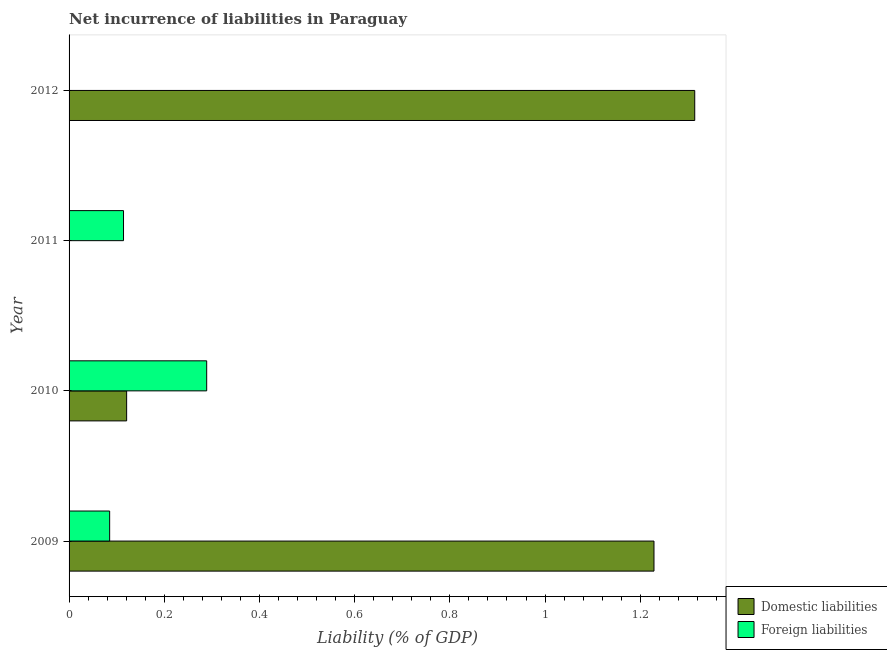How many different coloured bars are there?
Give a very brief answer. 2. Are the number of bars on each tick of the Y-axis equal?
Make the answer very short. No. What is the incurrence of foreign liabilities in 2011?
Keep it short and to the point. 0.11. Across all years, what is the maximum incurrence of foreign liabilities?
Give a very brief answer. 0.29. Across all years, what is the minimum incurrence of foreign liabilities?
Provide a short and direct response. 0. In which year was the incurrence of domestic liabilities maximum?
Ensure brevity in your answer.  2012. What is the total incurrence of foreign liabilities in the graph?
Offer a terse response. 0.49. What is the difference between the incurrence of foreign liabilities in 2009 and that in 2010?
Your response must be concise. -0.2. What is the difference between the incurrence of foreign liabilities in 2011 and the incurrence of domestic liabilities in 2012?
Keep it short and to the point. -1.2. What is the average incurrence of domestic liabilities per year?
Your answer should be very brief. 0.67. In the year 2010, what is the difference between the incurrence of domestic liabilities and incurrence of foreign liabilities?
Your response must be concise. -0.17. In how many years, is the incurrence of foreign liabilities greater than 0.2 %?
Provide a short and direct response. 1. What is the ratio of the incurrence of foreign liabilities in 2009 to that in 2011?
Keep it short and to the point. 0.74. Is the incurrence of domestic liabilities in 2010 less than that in 2012?
Provide a succinct answer. Yes. What is the difference between the highest and the second highest incurrence of domestic liabilities?
Make the answer very short. 0.09. What is the difference between the highest and the lowest incurrence of foreign liabilities?
Offer a very short reply. 0.29. In how many years, is the incurrence of domestic liabilities greater than the average incurrence of domestic liabilities taken over all years?
Provide a short and direct response. 2. What is the difference between two consecutive major ticks on the X-axis?
Your answer should be compact. 0.2. Does the graph contain grids?
Offer a very short reply. No. How many legend labels are there?
Ensure brevity in your answer.  2. How are the legend labels stacked?
Keep it short and to the point. Vertical. What is the title of the graph?
Offer a terse response. Net incurrence of liabilities in Paraguay. What is the label or title of the X-axis?
Ensure brevity in your answer.  Liability (% of GDP). What is the Liability (% of GDP) in Domestic liabilities in 2009?
Offer a very short reply. 1.23. What is the Liability (% of GDP) of Foreign liabilities in 2009?
Provide a short and direct response. 0.09. What is the Liability (% of GDP) of Domestic liabilities in 2010?
Keep it short and to the point. 0.12. What is the Liability (% of GDP) in Foreign liabilities in 2010?
Your response must be concise. 0.29. What is the Liability (% of GDP) of Foreign liabilities in 2011?
Keep it short and to the point. 0.11. What is the Liability (% of GDP) of Domestic liabilities in 2012?
Keep it short and to the point. 1.31. What is the Liability (% of GDP) in Foreign liabilities in 2012?
Offer a very short reply. 0. Across all years, what is the maximum Liability (% of GDP) in Domestic liabilities?
Keep it short and to the point. 1.31. Across all years, what is the maximum Liability (% of GDP) of Foreign liabilities?
Make the answer very short. 0.29. Across all years, what is the minimum Liability (% of GDP) in Domestic liabilities?
Your response must be concise. 0. What is the total Liability (% of GDP) of Domestic liabilities in the graph?
Keep it short and to the point. 2.66. What is the total Liability (% of GDP) of Foreign liabilities in the graph?
Provide a succinct answer. 0.49. What is the difference between the Liability (% of GDP) in Domestic liabilities in 2009 and that in 2010?
Make the answer very short. 1.11. What is the difference between the Liability (% of GDP) in Foreign liabilities in 2009 and that in 2010?
Offer a terse response. -0.2. What is the difference between the Liability (% of GDP) in Foreign liabilities in 2009 and that in 2011?
Provide a short and direct response. -0.03. What is the difference between the Liability (% of GDP) of Domestic liabilities in 2009 and that in 2012?
Give a very brief answer. -0.09. What is the difference between the Liability (% of GDP) in Foreign liabilities in 2010 and that in 2011?
Ensure brevity in your answer.  0.17. What is the difference between the Liability (% of GDP) of Domestic liabilities in 2010 and that in 2012?
Give a very brief answer. -1.19. What is the difference between the Liability (% of GDP) of Domestic liabilities in 2009 and the Liability (% of GDP) of Foreign liabilities in 2010?
Offer a very short reply. 0.94. What is the difference between the Liability (% of GDP) of Domestic liabilities in 2009 and the Liability (% of GDP) of Foreign liabilities in 2011?
Ensure brevity in your answer.  1.11. What is the difference between the Liability (% of GDP) of Domestic liabilities in 2010 and the Liability (% of GDP) of Foreign liabilities in 2011?
Offer a very short reply. 0.01. What is the average Liability (% of GDP) in Domestic liabilities per year?
Your response must be concise. 0.67. What is the average Liability (% of GDP) of Foreign liabilities per year?
Provide a succinct answer. 0.12. In the year 2009, what is the difference between the Liability (% of GDP) of Domestic liabilities and Liability (% of GDP) of Foreign liabilities?
Keep it short and to the point. 1.14. In the year 2010, what is the difference between the Liability (% of GDP) in Domestic liabilities and Liability (% of GDP) in Foreign liabilities?
Ensure brevity in your answer.  -0.17. What is the ratio of the Liability (% of GDP) of Domestic liabilities in 2009 to that in 2010?
Provide a succinct answer. 10.16. What is the ratio of the Liability (% of GDP) of Foreign liabilities in 2009 to that in 2010?
Make the answer very short. 0.29. What is the ratio of the Liability (% of GDP) of Foreign liabilities in 2009 to that in 2011?
Give a very brief answer. 0.75. What is the ratio of the Liability (% of GDP) of Domestic liabilities in 2009 to that in 2012?
Your answer should be compact. 0.93. What is the ratio of the Liability (% of GDP) in Foreign liabilities in 2010 to that in 2011?
Provide a succinct answer. 2.53. What is the ratio of the Liability (% of GDP) of Domestic liabilities in 2010 to that in 2012?
Offer a very short reply. 0.09. What is the difference between the highest and the second highest Liability (% of GDP) in Domestic liabilities?
Give a very brief answer. 0.09. What is the difference between the highest and the second highest Liability (% of GDP) in Foreign liabilities?
Ensure brevity in your answer.  0.17. What is the difference between the highest and the lowest Liability (% of GDP) in Domestic liabilities?
Your response must be concise. 1.31. What is the difference between the highest and the lowest Liability (% of GDP) of Foreign liabilities?
Your answer should be very brief. 0.29. 